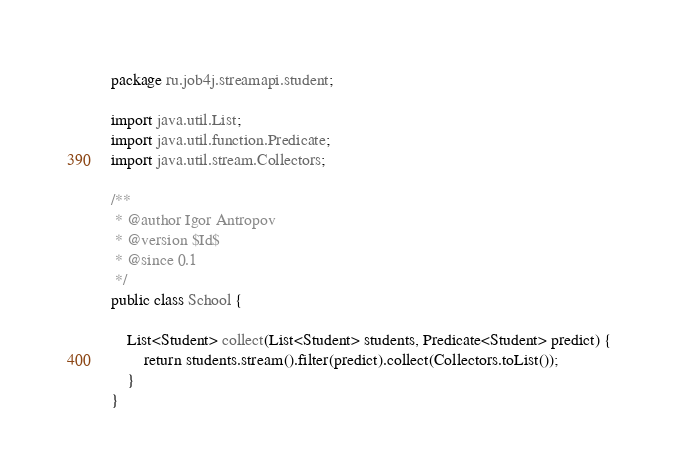<code> <loc_0><loc_0><loc_500><loc_500><_Java_>package ru.job4j.streamapi.student;

import java.util.List;
import java.util.function.Predicate;
import java.util.stream.Collectors;

/**
 * @author Igor Antropov
 * @version $Id$
 * @since 0.1
 */
public class School {

    List<Student> collect(List<Student> students, Predicate<Student> predict) {
        return students.stream().filter(predict).collect(Collectors.toList());
    }
}
</code> 